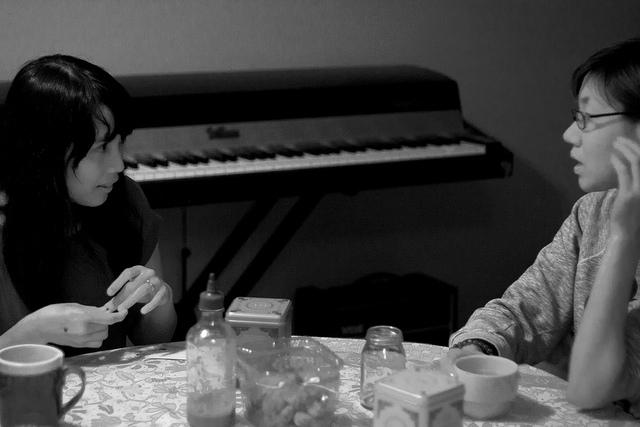What type musician lives here? Please explain your reasoning. pianist. It is a pianist because a piano is against the wall 